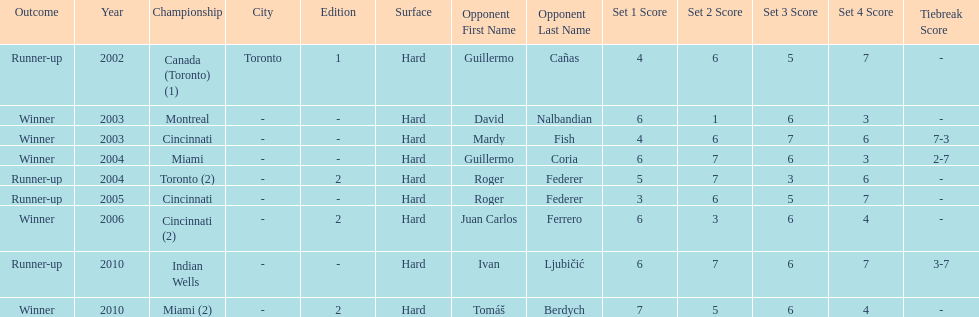What is his highest number of consecutive wins? 3. 